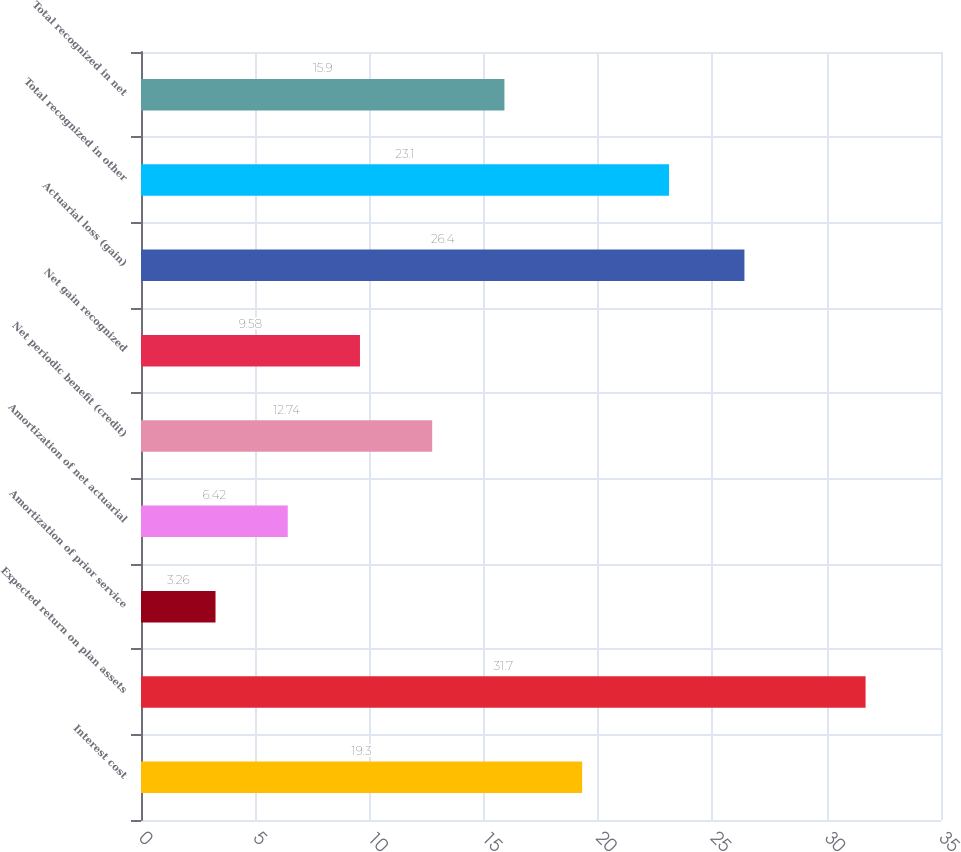Convert chart. <chart><loc_0><loc_0><loc_500><loc_500><bar_chart><fcel>Interest cost<fcel>Expected return on plan assets<fcel>Amortization of prior service<fcel>Amortization of net actuarial<fcel>Net periodic benefit (credit)<fcel>Net gain recognized<fcel>Actuarial loss (gain)<fcel>Total recognized in other<fcel>Total recognized in net<nl><fcel>19.3<fcel>31.7<fcel>3.26<fcel>6.42<fcel>12.74<fcel>9.58<fcel>26.4<fcel>23.1<fcel>15.9<nl></chart> 